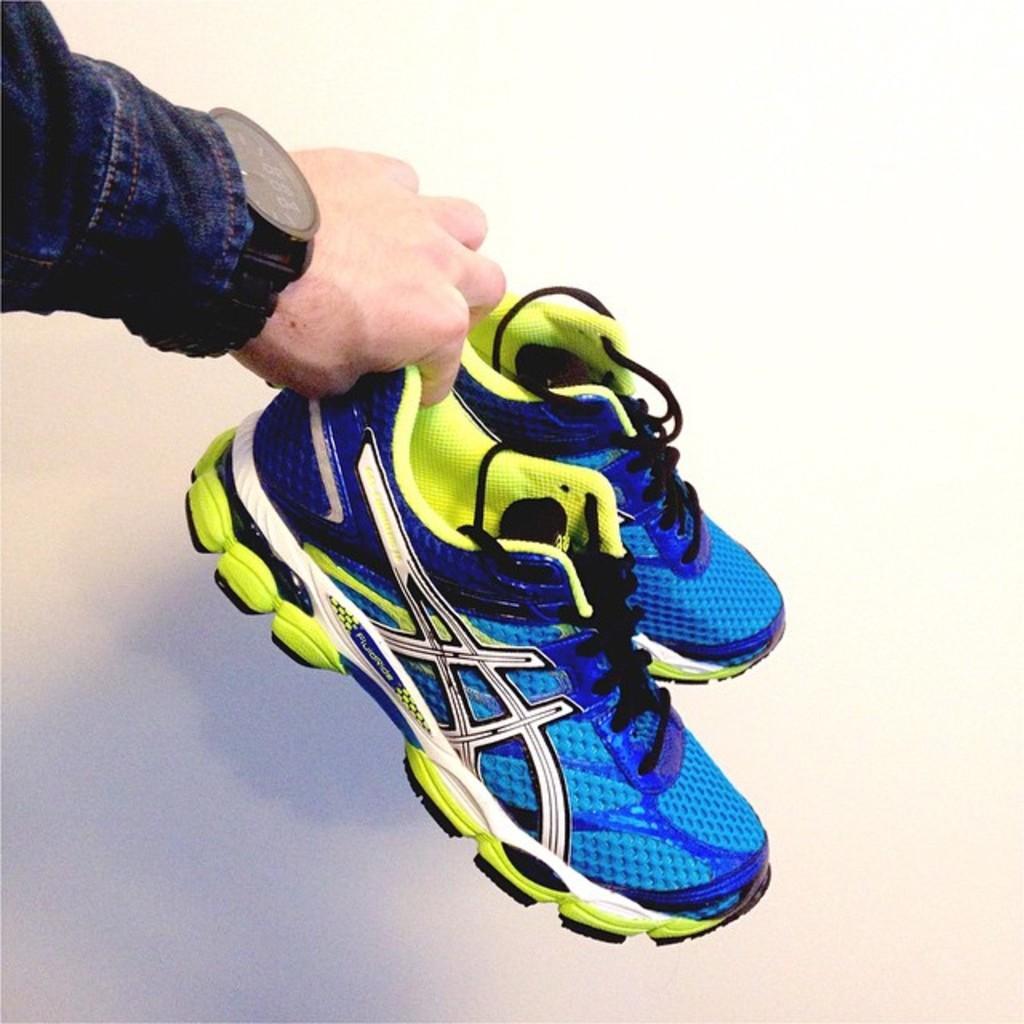Please provide a concise description of this image. In this image we can see the hand of a person holding the shoes. In the background of the image there is a wall. 